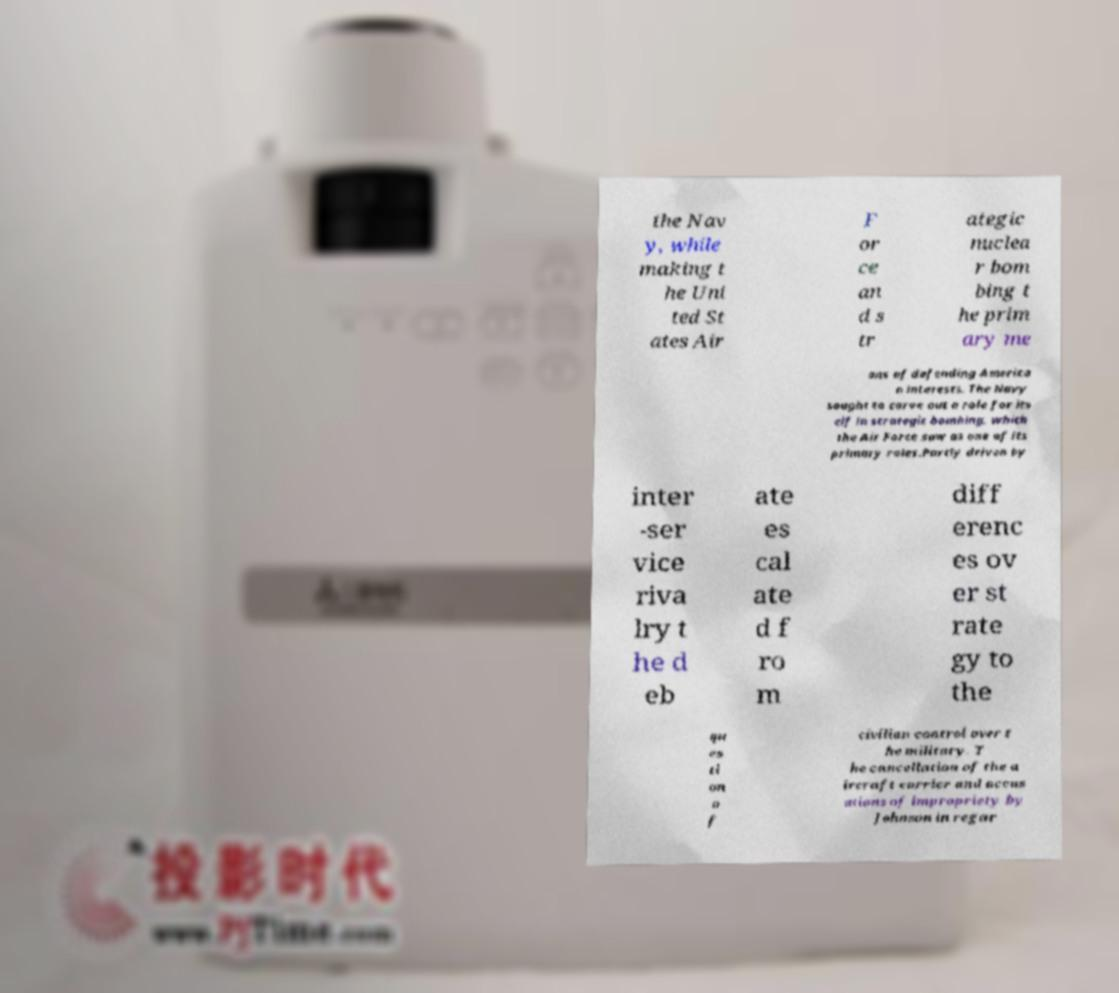Please identify and transcribe the text found in this image. the Nav y, while making t he Uni ted St ates Air F or ce an d s tr ategic nuclea r bom bing t he prim ary me ans of defending America n interests. The Navy sought to carve out a role for its elf in strategic bombing, which the Air Force saw as one of its primary roles.Partly driven by inter -ser vice riva lry t he d eb ate es cal ate d f ro m diff erenc es ov er st rate gy to the qu es ti on o f civilian control over t he military. T he cancellation of the a ircraft carrier and accus ations of impropriety by Johnson in regar 